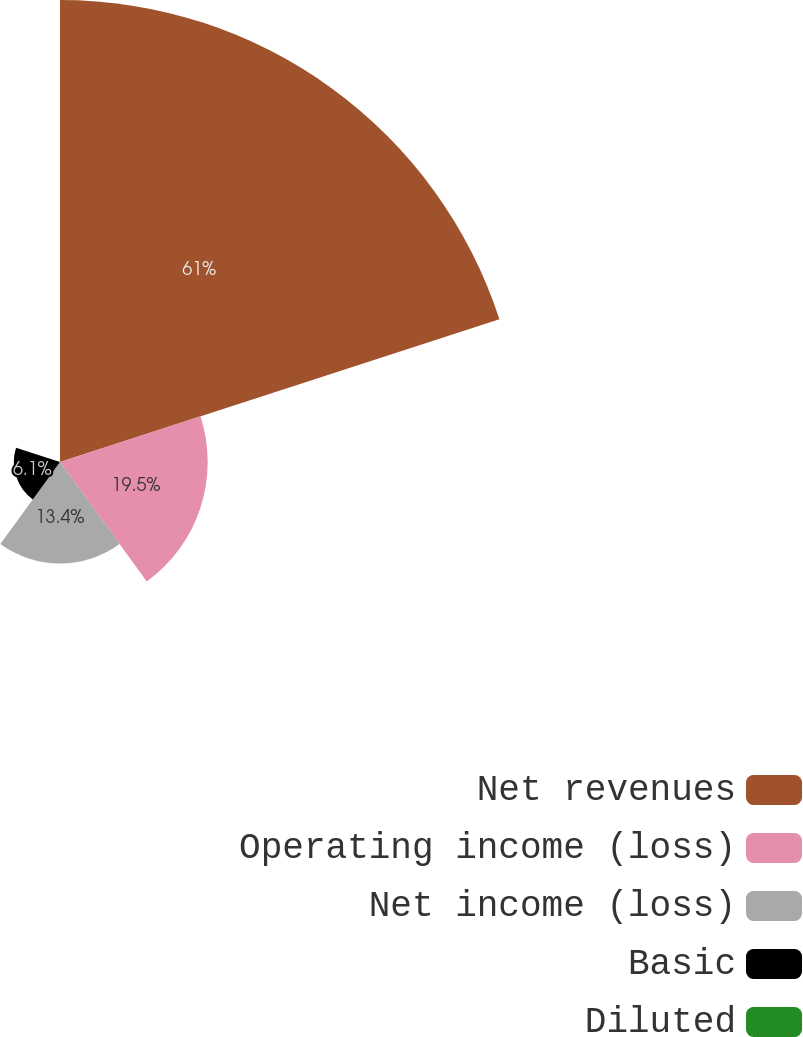<chart> <loc_0><loc_0><loc_500><loc_500><pie_chart><fcel>Net revenues<fcel>Operating income (loss)<fcel>Net income (loss)<fcel>Basic<fcel>Diluted<nl><fcel>61.0%<fcel>19.5%<fcel>13.4%<fcel>6.1%<fcel>0.0%<nl></chart> 